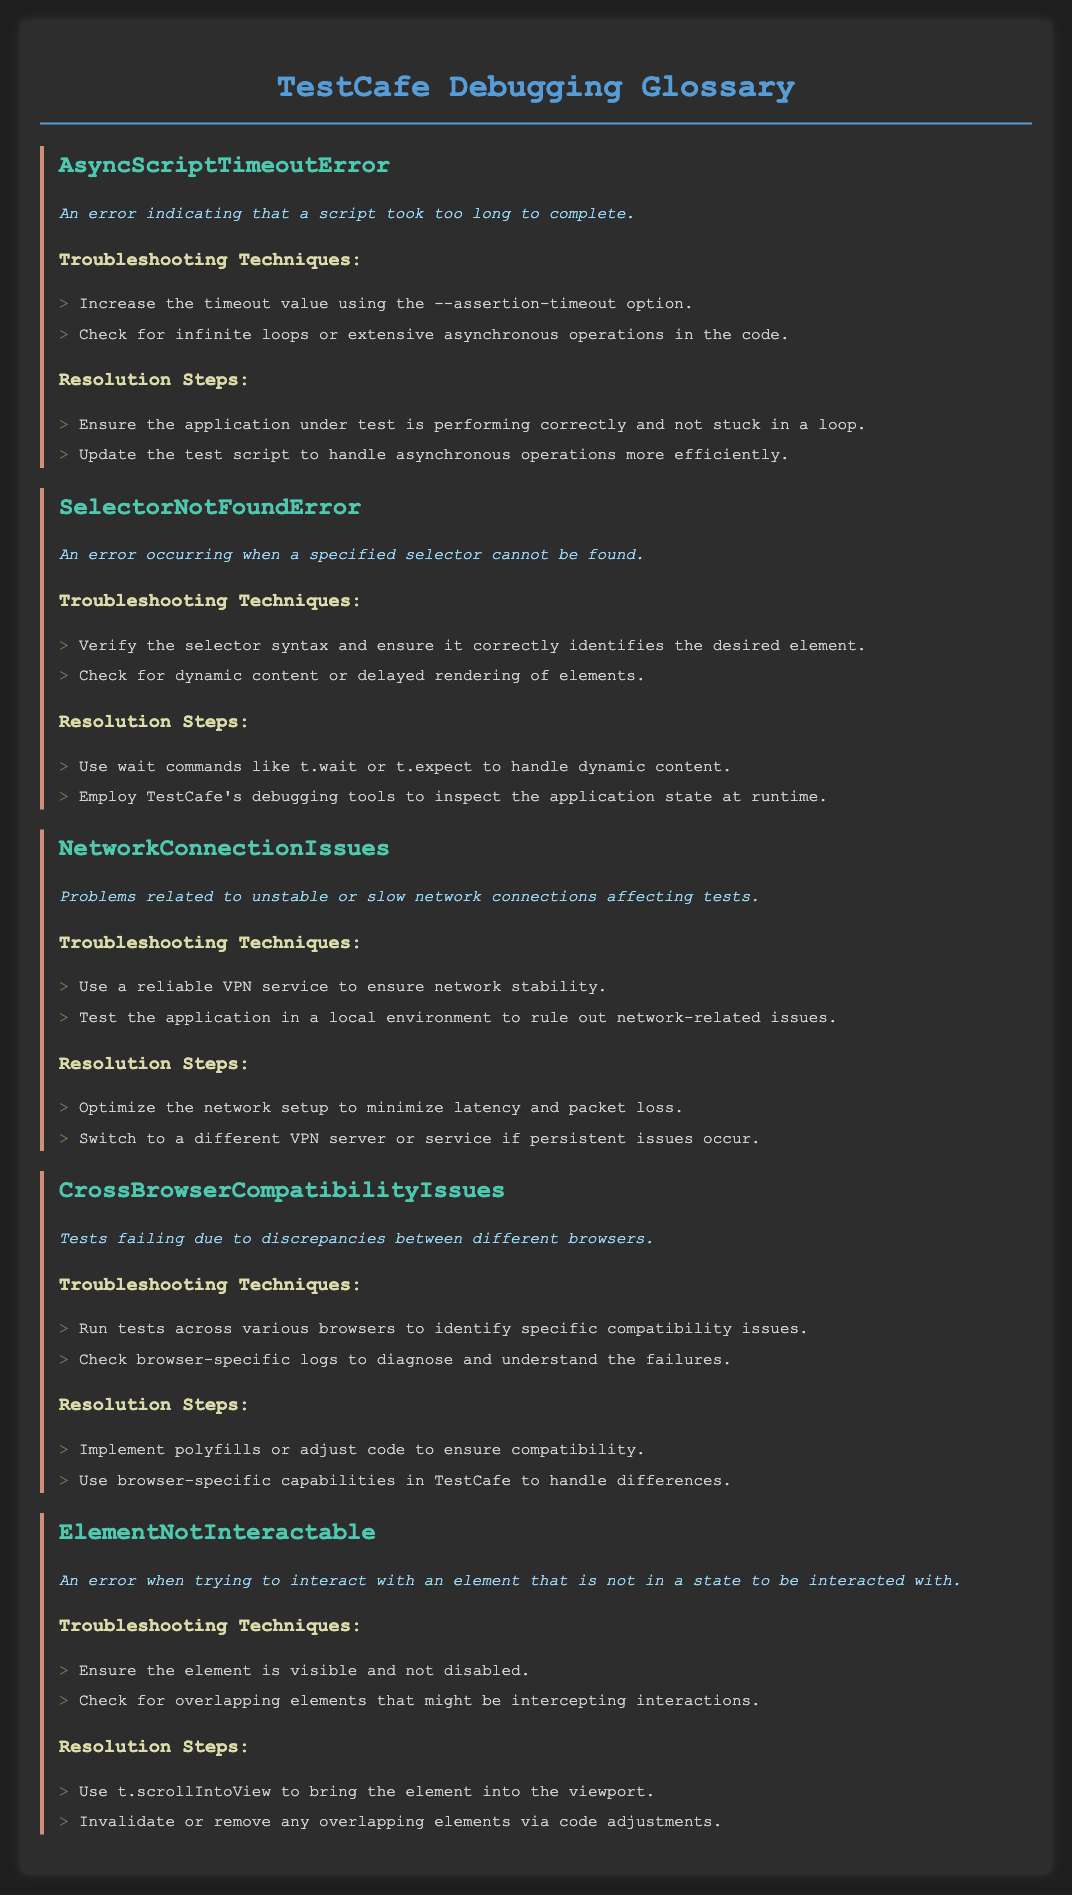What does AsyncScriptTimeoutError indicate? It indicates that a script took too long to complete, as described in the document.
Answer: A script took too long to complete What should be increased to troubleshoot AsyncScriptTimeoutError? The document suggests increasing the timeout value using the --assertion-timeout option for this error.
Answer: Timeout value What error occurs when a selector cannot be found? The document states that SelectorNotFoundError occurs when a specified selector cannot be found.
Answer: SelectorNotFoundError What should be used to handle dynamic content in tests? The document recommends using wait commands like t.wait or t.expect to handle dynamic content.
Answer: t.wait or t.expect What issues do NetworkConnectionIssues involve? The document references unstable or slow network connections affecting tests as a description of these issues.
Answer: Unstable or slow network connections What tool can be used to inspect application state at runtime? TestCafe's debugging tools can be employed to inspect the application state at runtime, according to the document.
Answer: TestCafe's debugging tools What is a common cause of CrossBrowserCompatibilityIssues? The document highlights discrepancies between different browsers as a common cause of these issues.
Answer: Discrepancies between different browsers What action should be taken if an element is not interactable? The document advises using t.scrollIntoView to bring the element into the viewport when it is not interactable.
Answer: t.scrollIntoView 